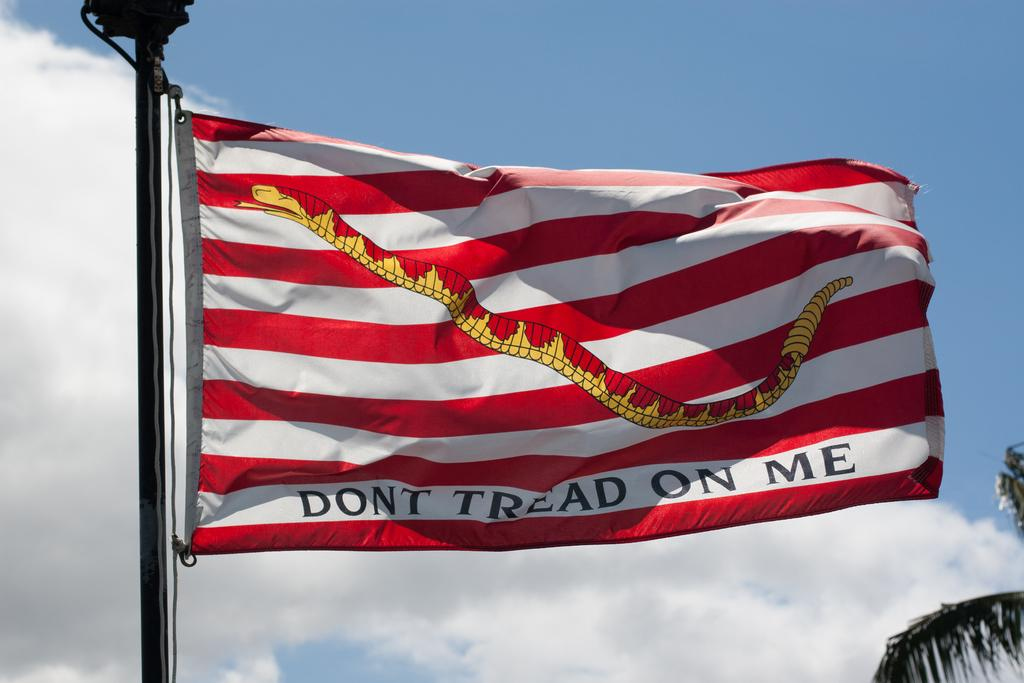What is featured on the flag in the image? There is a flag with text in the image. What type of natural element can be seen in the image? There is a tree in the image. What is visible in the background of the image? The sky is visible in the background of the image. What can be observed in the sky in the image? Clouds are present in the sky. What industry is depicted in the image? There is no industry present in the image; it features a flag with text, a tree, and a sky with clouds. 